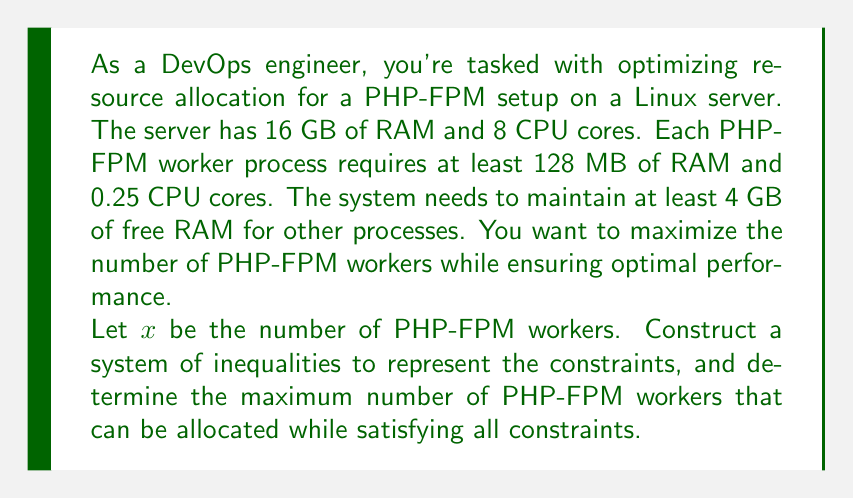Show me your answer to this math problem. Let's break this problem down step by step:

1. Define the variables:
   $x$ = number of PHP-FPM workers

2. Construct inequalities based on the given constraints:

   a) RAM constraint:
      Each worker uses 128 MB (0.128 GB) of RAM, and we need to keep 4 GB free.
      $$ 0.128x + 4 \leq 16 $$

   b) CPU constraint:
      Each worker uses 0.25 CPU cores.
      $$ 0.25x \leq 8 $$

   c) Non-negativity constraint:
      $$ x \geq 0 $$

3. Solve the inequalities:

   a) From the RAM constraint:
      $$ 0.128x \leq 12 $$
      $$ x \leq 93.75 $$

   b) From the CPU constraint:
      $$ x \leq 32 $$

4. Combine the constraints:
   The most restrictive upper bound is 32, from the CPU constraint.

5. Since we're dealing with whole workers, we round down to the nearest integer:
   Maximum number of workers = 32

6. Verify the solution:
   - RAM usage: $0.128 * 32 + 4 = 8.096$ GB (less than 16 GB)
   - CPU usage: $0.25 * 32 = 8$ cores (equal to 8, satisfying the constraint)

Therefore, the maximum number of PHP-FPM workers that can be allocated while satisfying all constraints is 32.
Answer: The maximum number of PHP-FPM workers that can be allocated is 32. 